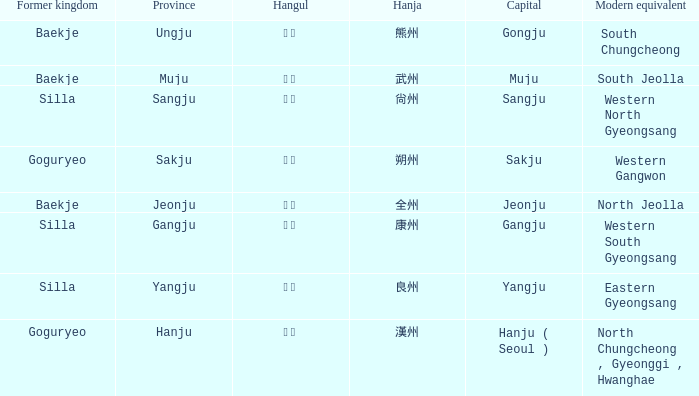What capital is represented by the hanja 尙州? Sangju. 